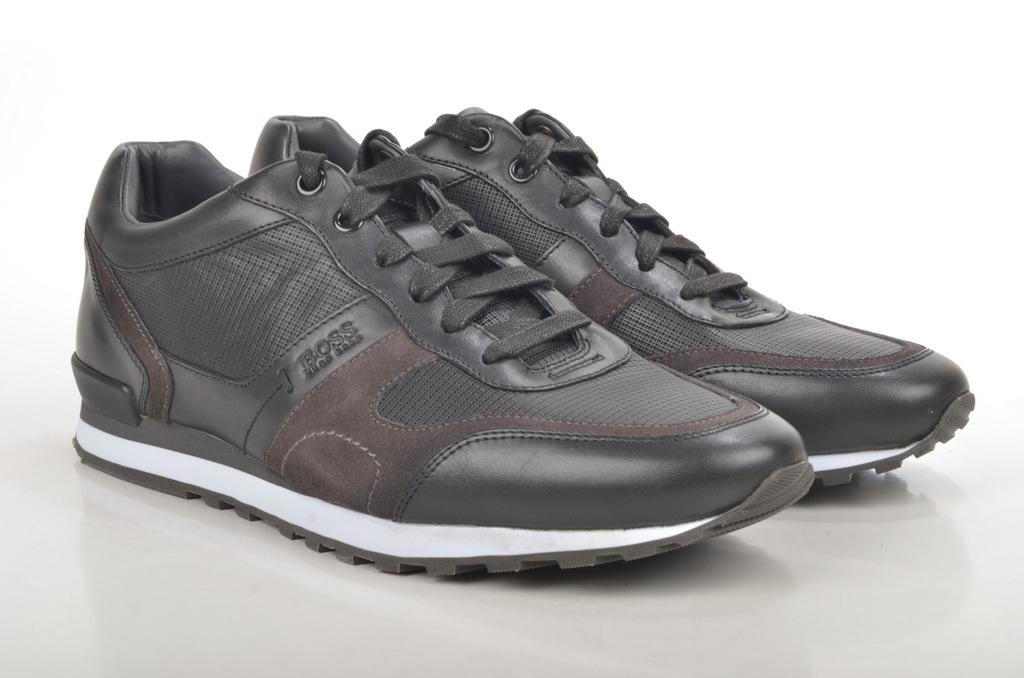What type of footwear is visible in the image? There is a pair of shoes in the image. What is the color of the floor where the shoes are placed? The shoes are on a white color floor. Where are the shoes located in the image? The shoes are in the middle of the image. What type of fuel is being used to power the shoes in the image? There is no indication in the image that the shoes are powered by any type of fuel. 